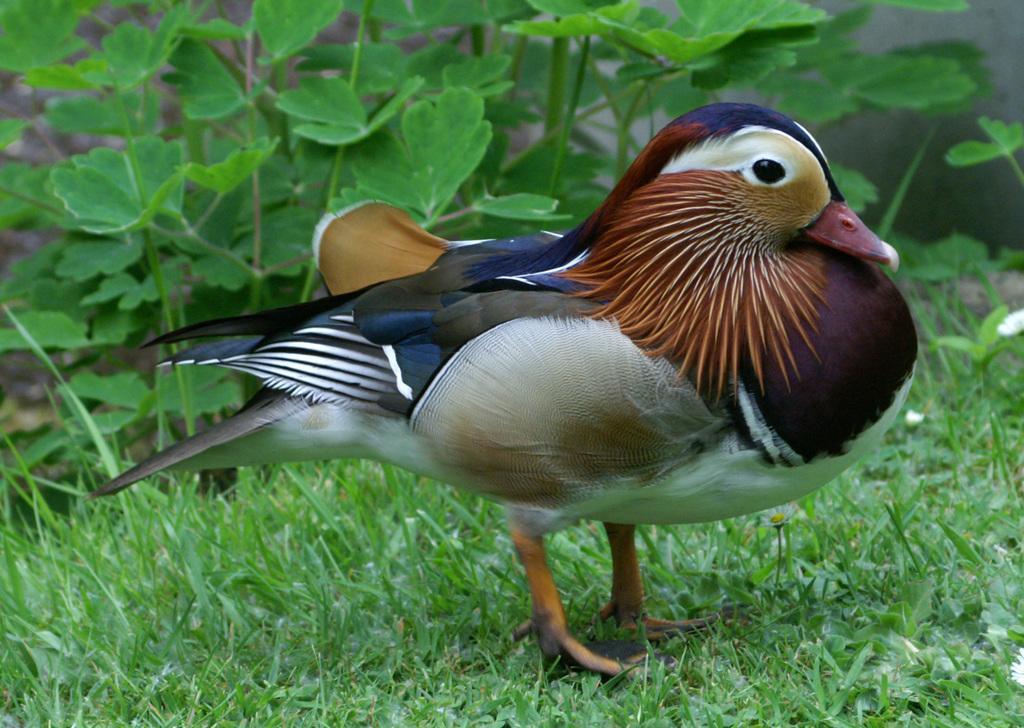Can you describe this image briefly? In this image I can see grass and on it I can see a bird is standing. I can see colour of the bird is white, blue, brown and little bit black. In the background I can see number of green colour leaves. 